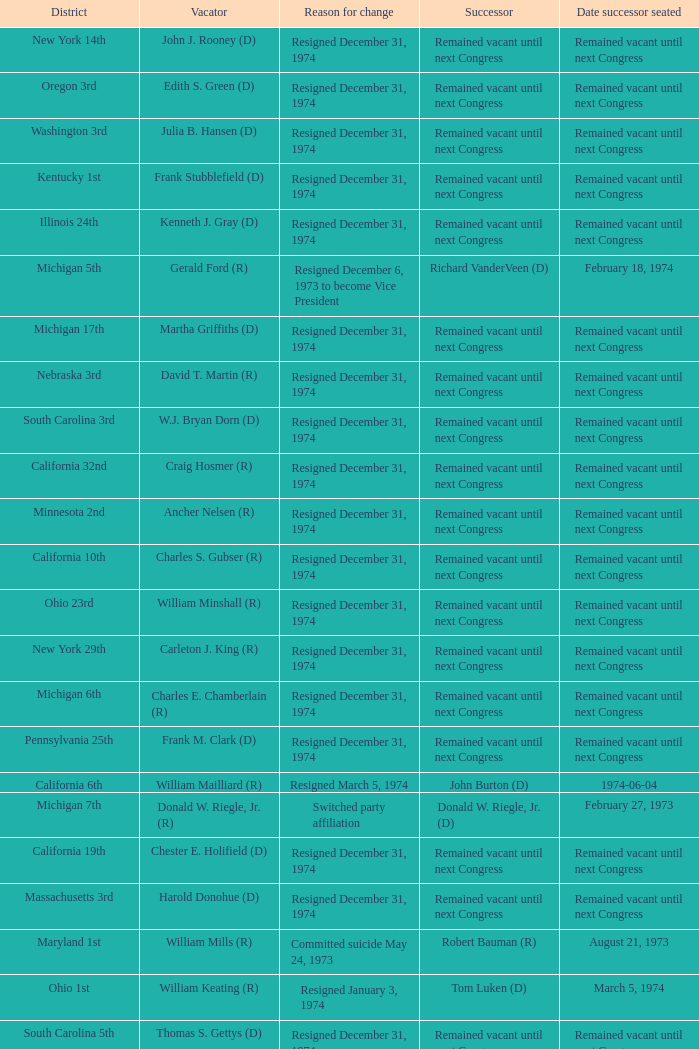What was the district when the motive for change deceased on january 1, 1974? California 13th. 